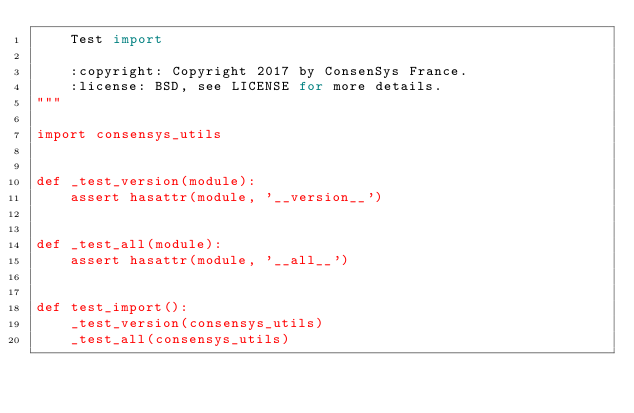<code> <loc_0><loc_0><loc_500><loc_500><_Python_>    Test import

    :copyright: Copyright 2017 by ConsenSys France.
    :license: BSD, see LICENSE for more details.
"""

import consensys_utils


def _test_version(module):
    assert hasattr(module, '__version__')


def _test_all(module):
    assert hasattr(module, '__all__')


def test_import():
    _test_version(consensys_utils)
    _test_all(consensys_utils)
</code> 